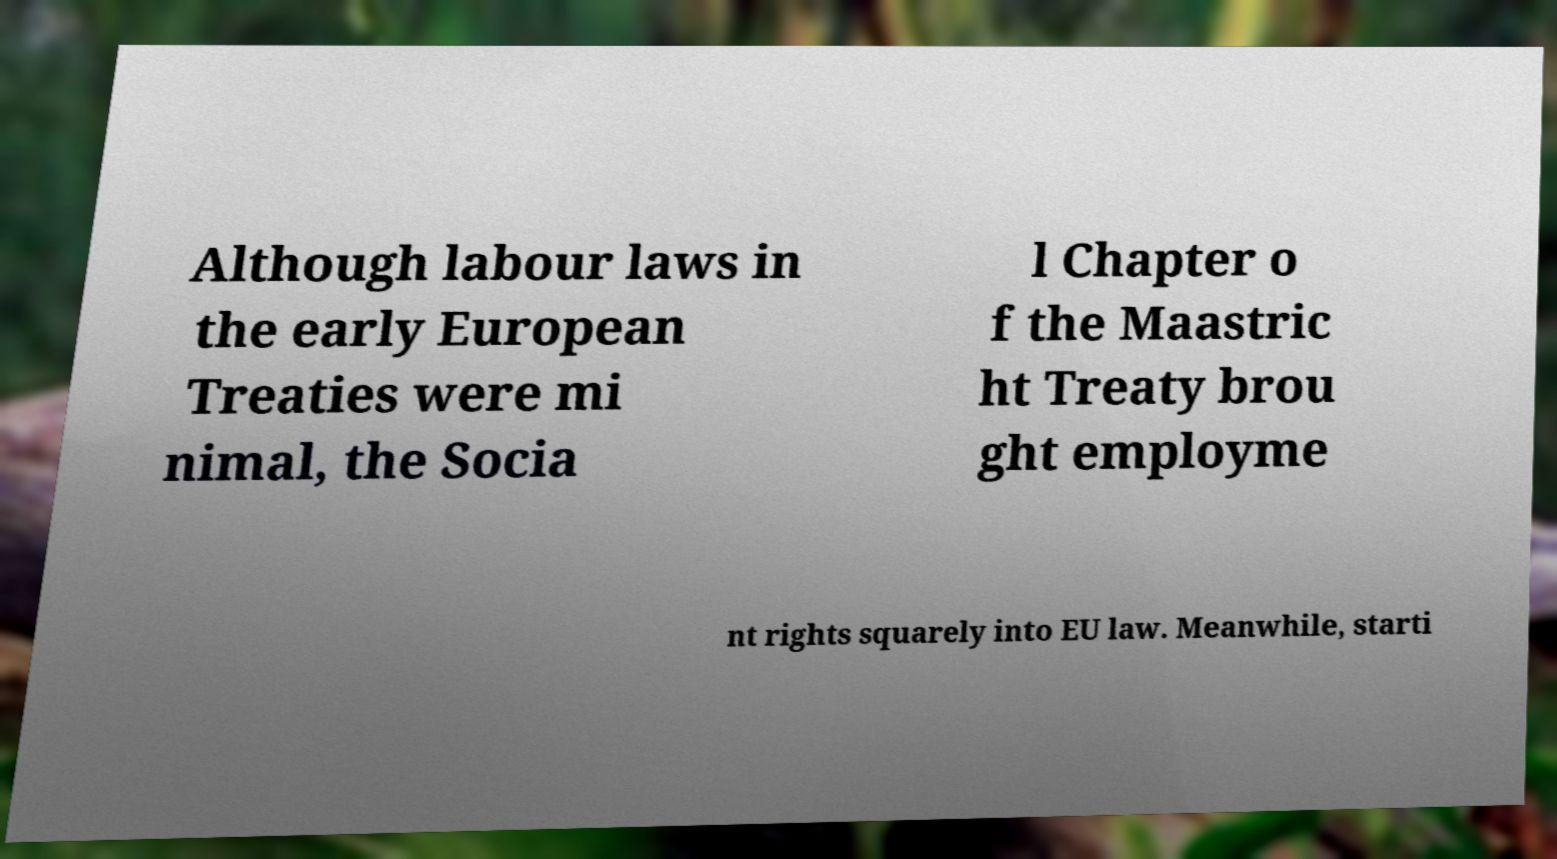Could you extract and type out the text from this image? Although labour laws in the early European Treaties were mi nimal, the Socia l Chapter o f the Maastric ht Treaty brou ght employme nt rights squarely into EU law. Meanwhile, starti 